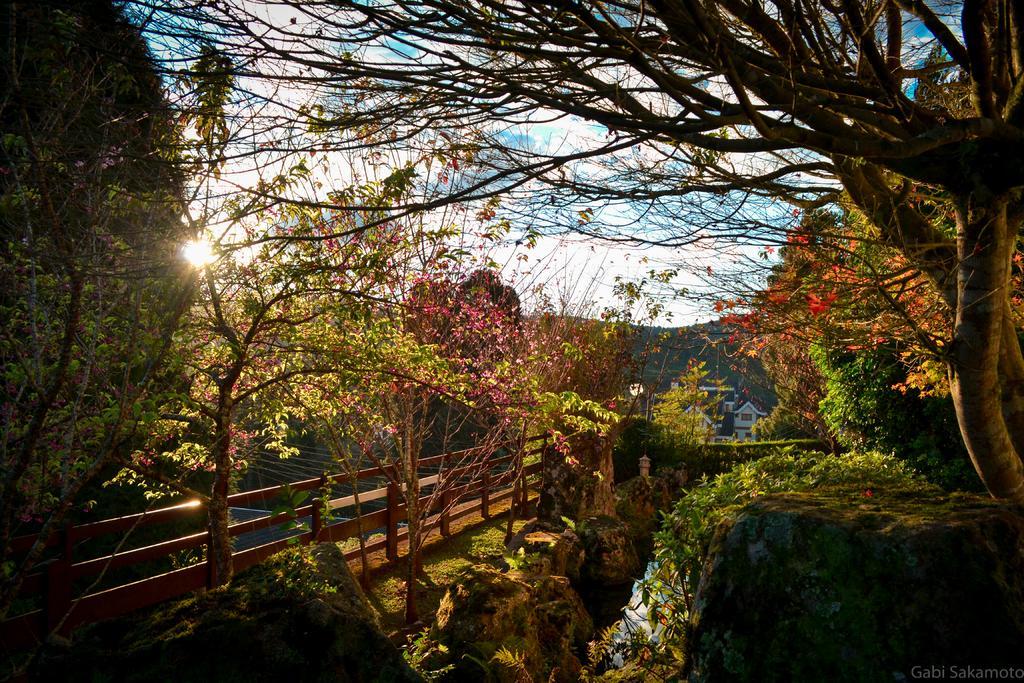How would you summarize this image in a sentence or two? In this image, there are a few trees, plants. We can see the ground with grass. We can also see the fence and some wires. We can see a building and the sun. We can see the sky with clouds. There are a few hills. 